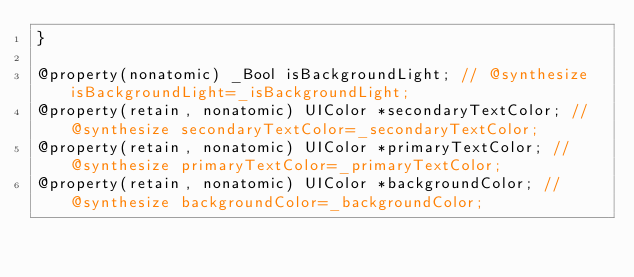Convert code to text. <code><loc_0><loc_0><loc_500><loc_500><_C_>}

@property(nonatomic) _Bool isBackgroundLight; // @synthesize isBackgroundLight=_isBackgroundLight;
@property(retain, nonatomic) UIColor *secondaryTextColor; // @synthesize secondaryTextColor=_secondaryTextColor;
@property(retain, nonatomic) UIColor *primaryTextColor; // @synthesize primaryTextColor=_primaryTextColor;
@property(retain, nonatomic) UIColor *backgroundColor; // @synthesize backgroundColor=_backgroundColor;</code> 